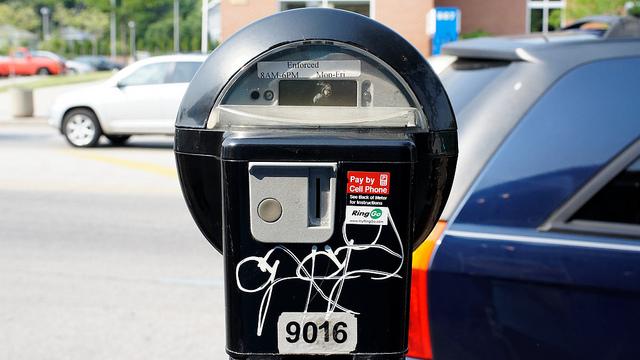What is the meter's number?
Short answer required. 9016. How many vehicles can this device serve?
Concise answer only. 1. Does the meter have any money in it?
Write a very short answer. Yes. Is this a double parking meter?
Keep it brief. No. What is parked near the meter?
Quick response, please. Car. 